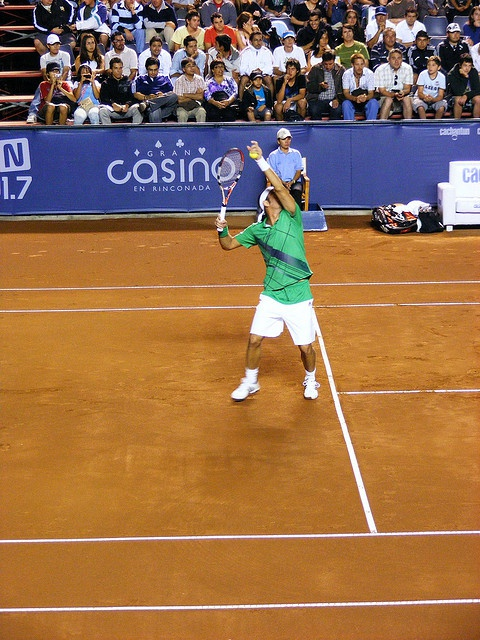Describe the objects in this image and their specific colors. I can see people in gray, black, blue, lavender, and red tones, people in gray, white, lightgreen, green, and olive tones, chair in gray, white, lavender, blue, and purple tones, people in gray, lightgray, and black tones, and people in gray, black, darkgray, and maroon tones in this image. 